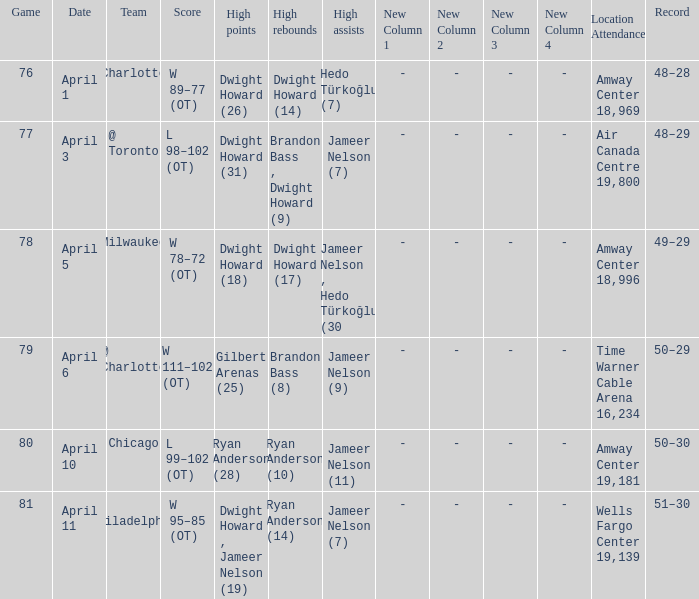Who had the most the most rebounds and how many did they have on April 1? Dwight Howard (14). 